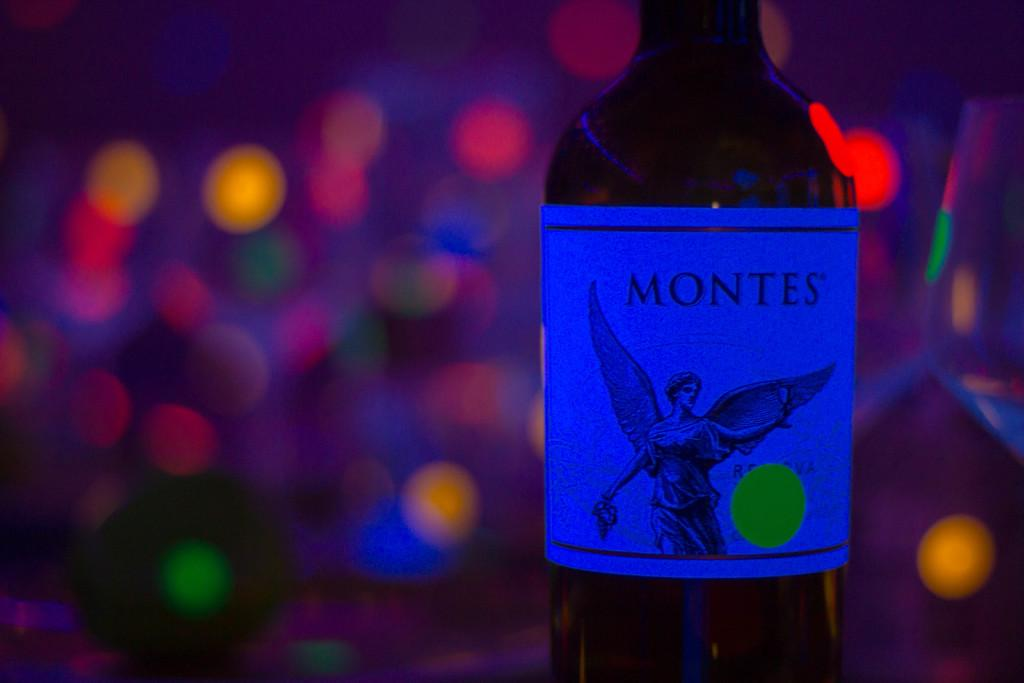<image>
Provide a brief description of the given image. A Montes bottle has a yellow circle sticker on the label. 